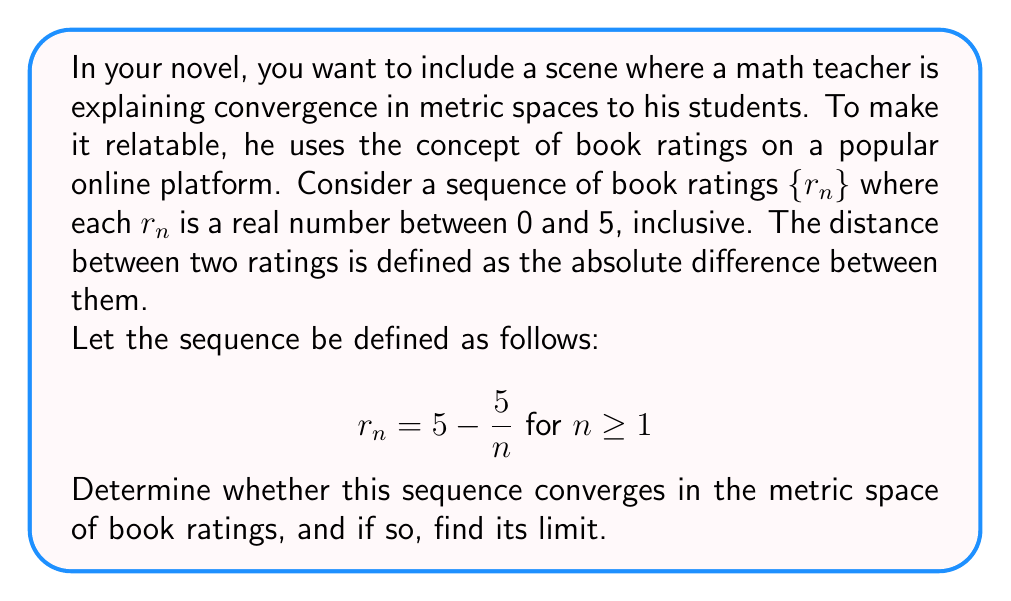Give your solution to this math problem. To analyze the convergence of this sequence in the metric space of book ratings, we'll follow these steps:

1) First, let's recall that in a metric space, a sequence $\{x_n\}$ converges to a limit $L$ if for every $\epsilon > 0$, there exists an $N \in \mathbb{N}$ such that $d(x_n, L) < \epsilon$ for all $n \geq N$, where $d$ is the metric (distance function).

2) In this case, our metric is $d(x,y) = |x-y|$, the absolute difference between ratings.

3) Let's examine the behavior of $r_n$ as $n$ approaches infinity:

   $$\lim_{n \to \infty} r_n = \lim_{n \to \infty} (5 - \frac{5}{n}) = 5 - \lim_{n \to \infty} \frac{5}{n} = 5 - 0 = 5$$

4) This suggests that the sequence might converge to 5. Let's prove it rigorously.

5) We need to show that for any $\epsilon > 0$, we can find an $N$ such that $|r_n - 5| < \epsilon$ for all $n \geq N$.

6) $|r_n - 5| = |(5 - \frac{5}{n}) - 5| = |\frac{-5}{n}| = \frac{5}{n}$

7) We want $\frac{5}{n} < \epsilon$, or equivalently, $n > \frac{5}{\epsilon}$

8) Therefore, we can choose $N = \lceil\frac{5}{\epsilon}\rceil$ (the ceiling function, smallest integer greater than or equal to $\frac{5}{\epsilon}$).

9) With this choice of $N$, for any $n \geq N$, we have:
   
   $$|r_n - 5| = \frac{5}{n} \leq \frac{5}{N} \leq \frac{5}{\frac{5}{\epsilon}} = \epsilon$$

10) This proves that the sequence converges to 5 in our metric space.

11) Note that all terms of the sequence are indeed in our space (between 0 and 5) as $5 - \frac{5}{n} \geq 0$ for all $n \geq 1$, and $5 - \frac{5}{n} \leq 5$ for all $n$.
Answer: The sequence converges in the metric space of book ratings, and its limit is 5. 